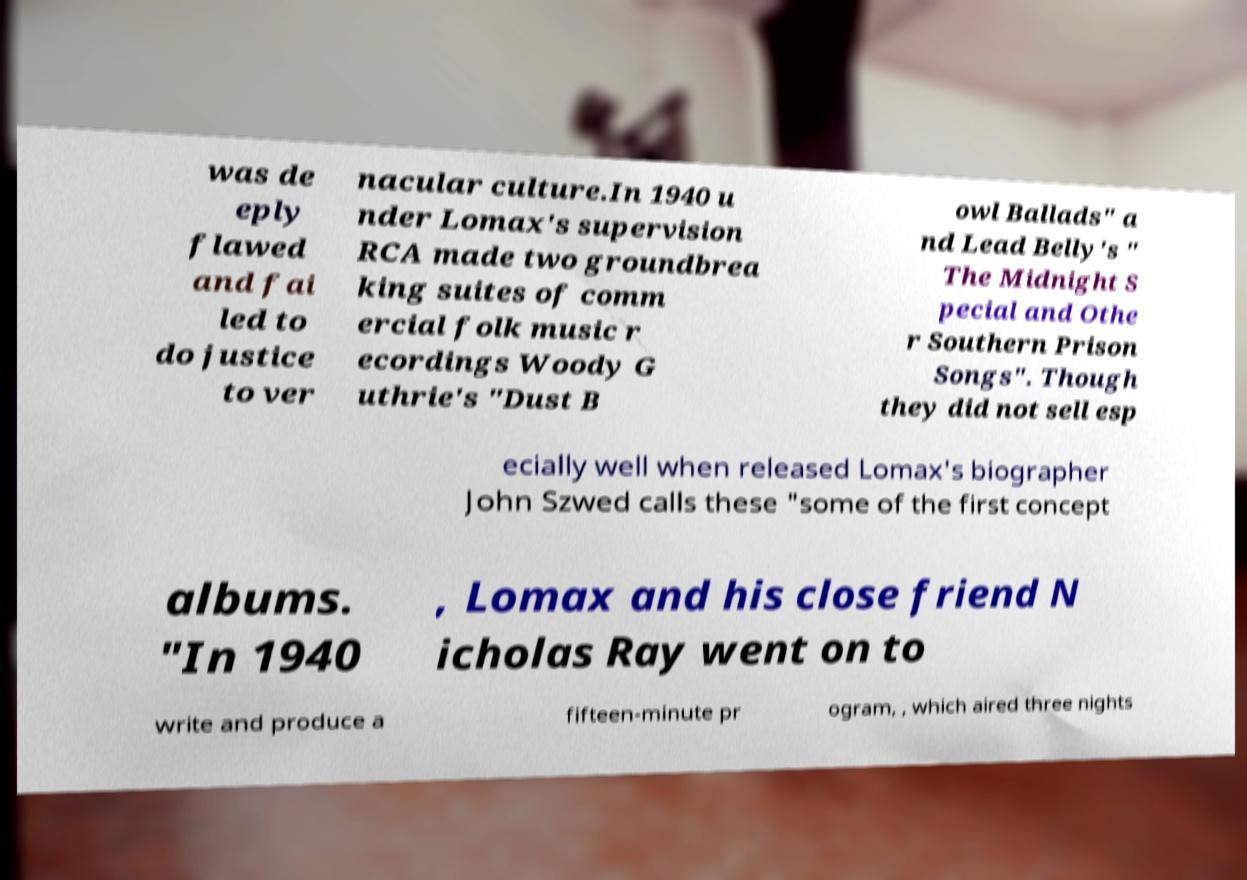Can you accurately transcribe the text from the provided image for me? was de eply flawed and fai led to do justice to ver nacular culture.In 1940 u nder Lomax's supervision RCA made two groundbrea king suites of comm ercial folk music r ecordings Woody G uthrie's "Dust B owl Ballads" a nd Lead Belly's " The Midnight S pecial and Othe r Southern Prison Songs". Though they did not sell esp ecially well when released Lomax's biographer John Szwed calls these "some of the first concept albums. "In 1940 , Lomax and his close friend N icholas Ray went on to write and produce a fifteen-minute pr ogram, , which aired three nights 